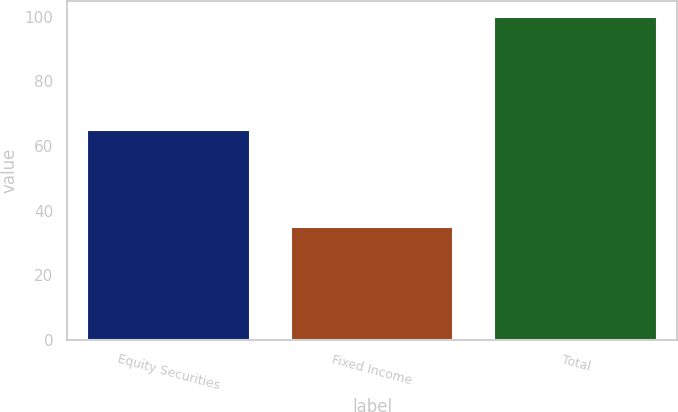Convert chart to OTSL. <chart><loc_0><loc_0><loc_500><loc_500><bar_chart><fcel>Equity Securities<fcel>Fixed Income<fcel>Total<nl><fcel>65<fcel>35<fcel>100<nl></chart> 